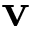Convert formula to latex. <formula><loc_0><loc_0><loc_500><loc_500>v</formula> 